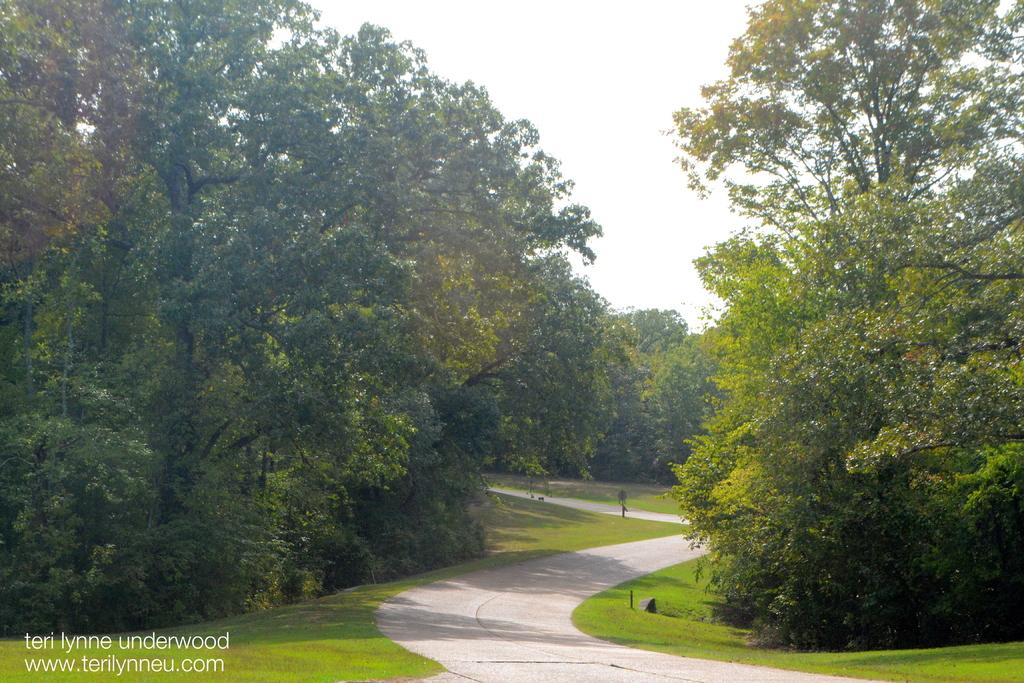What can be seen running through the image? There is a path in the image. What is located beside the path? Metal poles are present beside the path. What type of vegetation is visible in the image? Grass is visible in the image. What other natural elements can be seen in the image? Trees are present in the image. What is visible in the background of the image? The sky is visible in the background of the image. Where is the text located in the image? The text is in the bottom left corner of the image. What type of chin can be seen on the vessel in the image? There is no vessel present in the image, and therefore no chin to observe. How does the health of the trees in the image affect the overall appearance of the scene? The health of the trees is not mentioned in the provided facts, so it cannot be determined how it affects the overall appearance of the scene. 